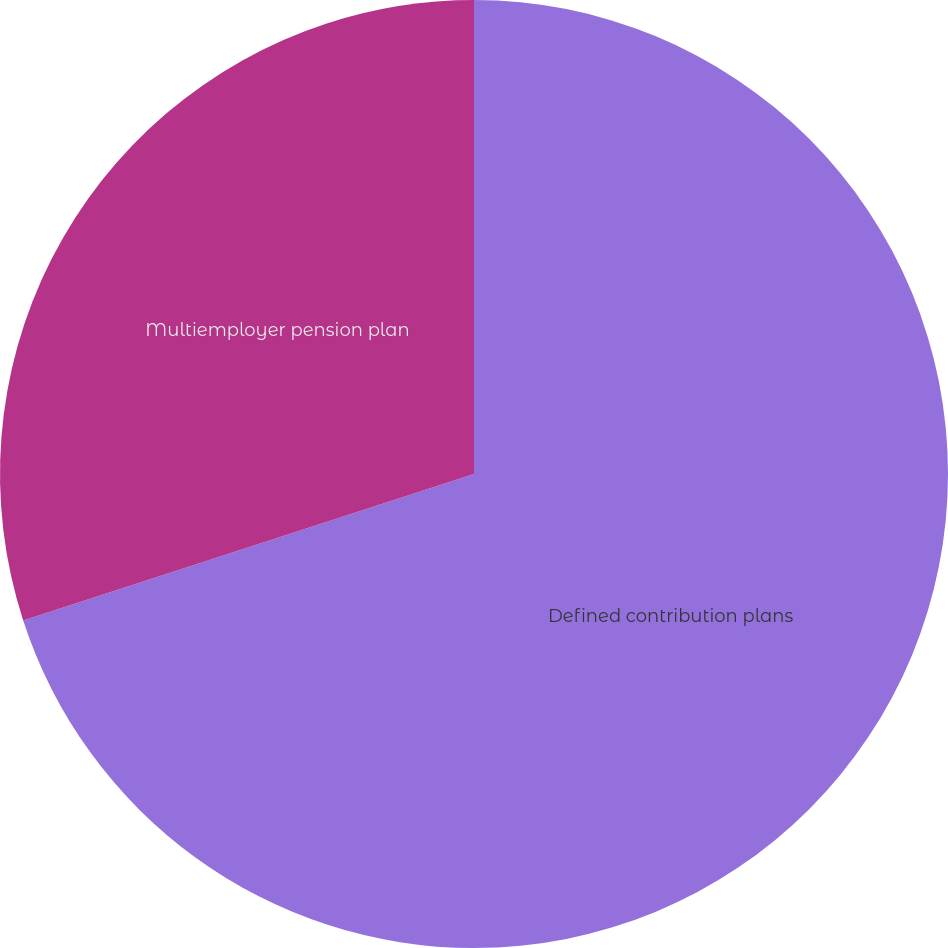Convert chart. <chart><loc_0><loc_0><loc_500><loc_500><pie_chart><fcel>Defined contribution plans<fcel>Multiemployer pension plan<nl><fcel>70.0%<fcel>30.0%<nl></chart> 